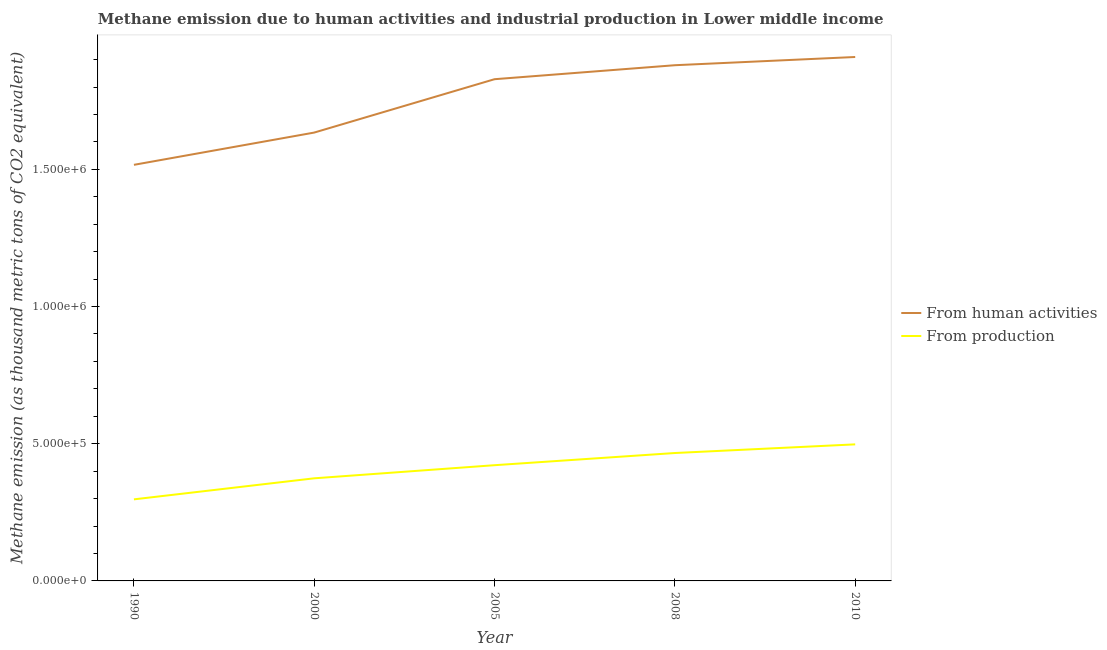How many different coloured lines are there?
Provide a succinct answer. 2. Does the line corresponding to amount of emissions generated from industries intersect with the line corresponding to amount of emissions from human activities?
Keep it short and to the point. No. Is the number of lines equal to the number of legend labels?
Your answer should be very brief. Yes. What is the amount of emissions from human activities in 2005?
Keep it short and to the point. 1.83e+06. Across all years, what is the maximum amount of emissions generated from industries?
Provide a short and direct response. 4.98e+05. Across all years, what is the minimum amount of emissions generated from industries?
Your answer should be very brief. 2.97e+05. What is the total amount of emissions generated from industries in the graph?
Make the answer very short. 2.06e+06. What is the difference between the amount of emissions from human activities in 2000 and that in 2010?
Provide a succinct answer. -2.75e+05. What is the difference between the amount of emissions from human activities in 2000 and the amount of emissions generated from industries in 1990?
Your response must be concise. 1.34e+06. What is the average amount of emissions from human activities per year?
Offer a terse response. 1.75e+06. In the year 2000, what is the difference between the amount of emissions from human activities and amount of emissions generated from industries?
Your answer should be compact. 1.26e+06. In how many years, is the amount of emissions generated from industries greater than 100000 thousand metric tons?
Your answer should be very brief. 5. What is the ratio of the amount of emissions from human activities in 1990 to that in 2008?
Offer a terse response. 0.81. Is the amount of emissions from human activities in 1990 less than that in 2005?
Offer a very short reply. Yes. Is the difference between the amount of emissions from human activities in 2005 and 2008 greater than the difference between the amount of emissions generated from industries in 2005 and 2008?
Offer a terse response. No. What is the difference between the highest and the second highest amount of emissions from human activities?
Keep it short and to the point. 3.00e+04. What is the difference between the highest and the lowest amount of emissions from human activities?
Keep it short and to the point. 3.93e+05. In how many years, is the amount of emissions generated from industries greater than the average amount of emissions generated from industries taken over all years?
Provide a short and direct response. 3. Does the amount of emissions generated from industries monotonically increase over the years?
Provide a short and direct response. Yes. Is the amount of emissions from human activities strictly greater than the amount of emissions generated from industries over the years?
Give a very brief answer. Yes. How many years are there in the graph?
Keep it short and to the point. 5. What is the difference between two consecutive major ticks on the Y-axis?
Provide a short and direct response. 5.00e+05. Are the values on the major ticks of Y-axis written in scientific E-notation?
Provide a short and direct response. Yes. Does the graph contain grids?
Your answer should be very brief. No. What is the title of the graph?
Your answer should be very brief. Methane emission due to human activities and industrial production in Lower middle income. What is the label or title of the X-axis?
Offer a terse response. Year. What is the label or title of the Y-axis?
Ensure brevity in your answer.  Methane emission (as thousand metric tons of CO2 equivalent). What is the Methane emission (as thousand metric tons of CO2 equivalent) in From human activities in 1990?
Offer a very short reply. 1.52e+06. What is the Methane emission (as thousand metric tons of CO2 equivalent) in From production in 1990?
Your answer should be compact. 2.97e+05. What is the Methane emission (as thousand metric tons of CO2 equivalent) in From human activities in 2000?
Make the answer very short. 1.63e+06. What is the Methane emission (as thousand metric tons of CO2 equivalent) of From production in 2000?
Offer a terse response. 3.74e+05. What is the Methane emission (as thousand metric tons of CO2 equivalent) in From human activities in 2005?
Offer a very short reply. 1.83e+06. What is the Methane emission (as thousand metric tons of CO2 equivalent) of From production in 2005?
Your answer should be very brief. 4.22e+05. What is the Methane emission (as thousand metric tons of CO2 equivalent) in From human activities in 2008?
Ensure brevity in your answer.  1.88e+06. What is the Methane emission (as thousand metric tons of CO2 equivalent) in From production in 2008?
Offer a very short reply. 4.66e+05. What is the Methane emission (as thousand metric tons of CO2 equivalent) of From human activities in 2010?
Your answer should be compact. 1.91e+06. What is the Methane emission (as thousand metric tons of CO2 equivalent) of From production in 2010?
Offer a very short reply. 4.98e+05. Across all years, what is the maximum Methane emission (as thousand metric tons of CO2 equivalent) of From human activities?
Provide a short and direct response. 1.91e+06. Across all years, what is the maximum Methane emission (as thousand metric tons of CO2 equivalent) of From production?
Ensure brevity in your answer.  4.98e+05. Across all years, what is the minimum Methane emission (as thousand metric tons of CO2 equivalent) in From human activities?
Your answer should be compact. 1.52e+06. Across all years, what is the minimum Methane emission (as thousand metric tons of CO2 equivalent) of From production?
Keep it short and to the point. 2.97e+05. What is the total Methane emission (as thousand metric tons of CO2 equivalent) of From human activities in the graph?
Offer a very short reply. 8.77e+06. What is the total Methane emission (as thousand metric tons of CO2 equivalent) of From production in the graph?
Provide a succinct answer. 2.06e+06. What is the difference between the Methane emission (as thousand metric tons of CO2 equivalent) in From human activities in 1990 and that in 2000?
Provide a short and direct response. -1.18e+05. What is the difference between the Methane emission (as thousand metric tons of CO2 equivalent) of From production in 1990 and that in 2000?
Provide a succinct answer. -7.67e+04. What is the difference between the Methane emission (as thousand metric tons of CO2 equivalent) in From human activities in 1990 and that in 2005?
Your answer should be very brief. -3.12e+05. What is the difference between the Methane emission (as thousand metric tons of CO2 equivalent) of From production in 1990 and that in 2005?
Make the answer very short. -1.24e+05. What is the difference between the Methane emission (as thousand metric tons of CO2 equivalent) in From human activities in 1990 and that in 2008?
Ensure brevity in your answer.  -3.63e+05. What is the difference between the Methane emission (as thousand metric tons of CO2 equivalent) of From production in 1990 and that in 2008?
Offer a terse response. -1.69e+05. What is the difference between the Methane emission (as thousand metric tons of CO2 equivalent) in From human activities in 1990 and that in 2010?
Ensure brevity in your answer.  -3.93e+05. What is the difference between the Methane emission (as thousand metric tons of CO2 equivalent) of From production in 1990 and that in 2010?
Your response must be concise. -2.00e+05. What is the difference between the Methane emission (as thousand metric tons of CO2 equivalent) in From human activities in 2000 and that in 2005?
Keep it short and to the point. -1.94e+05. What is the difference between the Methane emission (as thousand metric tons of CO2 equivalent) of From production in 2000 and that in 2005?
Your response must be concise. -4.78e+04. What is the difference between the Methane emission (as thousand metric tons of CO2 equivalent) in From human activities in 2000 and that in 2008?
Provide a short and direct response. -2.45e+05. What is the difference between the Methane emission (as thousand metric tons of CO2 equivalent) in From production in 2000 and that in 2008?
Give a very brief answer. -9.21e+04. What is the difference between the Methane emission (as thousand metric tons of CO2 equivalent) in From human activities in 2000 and that in 2010?
Provide a succinct answer. -2.75e+05. What is the difference between the Methane emission (as thousand metric tons of CO2 equivalent) of From production in 2000 and that in 2010?
Give a very brief answer. -1.24e+05. What is the difference between the Methane emission (as thousand metric tons of CO2 equivalent) in From human activities in 2005 and that in 2008?
Make the answer very short. -5.09e+04. What is the difference between the Methane emission (as thousand metric tons of CO2 equivalent) in From production in 2005 and that in 2008?
Give a very brief answer. -4.44e+04. What is the difference between the Methane emission (as thousand metric tons of CO2 equivalent) of From human activities in 2005 and that in 2010?
Provide a short and direct response. -8.09e+04. What is the difference between the Methane emission (as thousand metric tons of CO2 equivalent) in From production in 2005 and that in 2010?
Ensure brevity in your answer.  -7.59e+04. What is the difference between the Methane emission (as thousand metric tons of CO2 equivalent) of From human activities in 2008 and that in 2010?
Ensure brevity in your answer.  -3.00e+04. What is the difference between the Methane emission (as thousand metric tons of CO2 equivalent) in From production in 2008 and that in 2010?
Your response must be concise. -3.16e+04. What is the difference between the Methane emission (as thousand metric tons of CO2 equivalent) of From human activities in 1990 and the Methane emission (as thousand metric tons of CO2 equivalent) of From production in 2000?
Ensure brevity in your answer.  1.14e+06. What is the difference between the Methane emission (as thousand metric tons of CO2 equivalent) in From human activities in 1990 and the Methane emission (as thousand metric tons of CO2 equivalent) in From production in 2005?
Make the answer very short. 1.09e+06. What is the difference between the Methane emission (as thousand metric tons of CO2 equivalent) of From human activities in 1990 and the Methane emission (as thousand metric tons of CO2 equivalent) of From production in 2008?
Give a very brief answer. 1.05e+06. What is the difference between the Methane emission (as thousand metric tons of CO2 equivalent) of From human activities in 1990 and the Methane emission (as thousand metric tons of CO2 equivalent) of From production in 2010?
Provide a succinct answer. 1.02e+06. What is the difference between the Methane emission (as thousand metric tons of CO2 equivalent) of From human activities in 2000 and the Methane emission (as thousand metric tons of CO2 equivalent) of From production in 2005?
Ensure brevity in your answer.  1.21e+06. What is the difference between the Methane emission (as thousand metric tons of CO2 equivalent) of From human activities in 2000 and the Methane emission (as thousand metric tons of CO2 equivalent) of From production in 2008?
Your answer should be compact. 1.17e+06. What is the difference between the Methane emission (as thousand metric tons of CO2 equivalent) of From human activities in 2000 and the Methane emission (as thousand metric tons of CO2 equivalent) of From production in 2010?
Your answer should be very brief. 1.14e+06. What is the difference between the Methane emission (as thousand metric tons of CO2 equivalent) in From human activities in 2005 and the Methane emission (as thousand metric tons of CO2 equivalent) in From production in 2008?
Keep it short and to the point. 1.36e+06. What is the difference between the Methane emission (as thousand metric tons of CO2 equivalent) of From human activities in 2005 and the Methane emission (as thousand metric tons of CO2 equivalent) of From production in 2010?
Your answer should be compact. 1.33e+06. What is the difference between the Methane emission (as thousand metric tons of CO2 equivalent) in From human activities in 2008 and the Methane emission (as thousand metric tons of CO2 equivalent) in From production in 2010?
Your answer should be very brief. 1.38e+06. What is the average Methane emission (as thousand metric tons of CO2 equivalent) of From human activities per year?
Offer a very short reply. 1.75e+06. What is the average Methane emission (as thousand metric tons of CO2 equivalent) of From production per year?
Give a very brief answer. 4.11e+05. In the year 1990, what is the difference between the Methane emission (as thousand metric tons of CO2 equivalent) in From human activities and Methane emission (as thousand metric tons of CO2 equivalent) in From production?
Your response must be concise. 1.22e+06. In the year 2000, what is the difference between the Methane emission (as thousand metric tons of CO2 equivalent) of From human activities and Methane emission (as thousand metric tons of CO2 equivalent) of From production?
Your response must be concise. 1.26e+06. In the year 2005, what is the difference between the Methane emission (as thousand metric tons of CO2 equivalent) in From human activities and Methane emission (as thousand metric tons of CO2 equivalent) in From production?
Offer a terse response. 1.41e+06. In the year 2008, what is the difference between the Methane emission (as thousand metric tons of CO2 equivalent) in From human activities and Methane emission (as thousand metric tons of CO2 equivalent) in From production?
Offer a terse response. 1.41e+06. In the year 2010, what is the difference between the Methane emission (as thousand metric tons of CO2 equivalent) in From human activities and Methane emission (as thousand metric tons of CO2 equivalent) in From production?
Give a very brief answer. 1.41e+06. What is the ratio of the Methane emission (as thousand metric tons of CO2 equivalent) of From human activities in 1990 to that in 2000?
Provide a succinct answer. 0.93. What is the ratio of the Methane emission (as thousand metric tons of CO2 equivalent) in From production in 1990 to that in 2000?
Your answer should be compact. 0.79. What is the ratio of the Methane emission (as thousand metric tons of CO2 equivalent) of From human activities in 1990 to that in 2005?
Provide a succinct answer. 0.83. What is the ratio of the Methane emission (as thousand metric tons of CO2 equivalent) of From production in 1990 to that in 2005?
Your response must be concise. 0.7. What is the ratio of the Methane emission (as thousand metric tons of CO2 equivalent) of From human activities in 1990 to that in 2008?
Give a very brief answer. 0.81. What is the ratio of the Methane emission (as thousand metric tons of CO2 equivalent) of From production in 1990 to that in 2008?
Give a very brief answer. 0.64. What is the ratio of the Methane emission (as thousand metric tons of CO2 equivalent) in From human activities in 1990 to that in 2010?
Your answer should be compact. 0.79. What is the ratio of the Methane emission (as thousand metric tons of CO2 equivalent) in From production in 1990 to that in 2010?
Your answer should be compact. 0.6. What is the ratio of the Methane emission (as thousand metric tons of CO2 equivalent) in From human activities in 2000 to that in 2005?
Provide a short and direct response. 0.89. What is the ratio of the Methane emission (as thousand metric tons of CO2 equivalent) in From production in 2000 to that in 2005?
Your answer should be very brief. 0.89. What is the ratio of the Methane emission (as thousand metric tons of CO2 equivalent) of From human activities in 2000 to that in 2008?
Offer a terse response. 0.87. What is the ratio of the Methane emission (as thousand metric tons of CO2 equivalent) in From production in 2000 to that in 2008?
Ensure brevity in your answer.  0.8. What is the ratio of the Methane emission (as thousand metric tons of CO2 equivalent) in From human activities in 2000 to that in 2010?
Make the answer very short. 0.86. What is the ratio of the Methane emission (as thousand metric tons of CO2 equivalent) in From production in 2000 to that in 2010?
Provide a succinct answer. 0.75. What is the ratio of the Methane emission (as thousand metric tons of CO2 equivalent) of From human activities in 2005 to that in 2008?
Ensure brevity in your answer.  0.97. What is the ratio of the Methane emission (as thousand metric tons of CO2 equivalent) in From production in 2005 to that in 2008?
Your answer should be compact. 0.9. What is the ratio of the Methane emission (as thousand metric tons of CO2 equivalent) in From human activities in 2005 to that in 2010?
Provide a short and direct response. 0.96. What is the ratio of the Methane emission (as thousand metric tons of CO2 equivalent) of From production in 2005 to that in 2010?
Provide a short and direct response. 0.85. What is the ratio of the Methane emission (as thousand metric tons of CO2 equivalent) in From human activities in 2008 to that in 2010?
Provide a short and direct response. 0.98. What is the ratio of the Methane emission (as thousand metric tons of CO2 equivalent) of From production in 2008 to that in 2010?
Keep it short and to the point. 0.94. What is the difference between the highest and the second highest Methane emission (as thousand metric tons of CO2 equivalent) in From human activities?
Your answer should be very brief. 3.00e+04. What is the difference between the highest and the second highest Methane emission (as thousand metric tons of CO2 equivalent) of From production?
Give a very brief answer. 3.16e+04. What is the difference between the highest and the lowest Methane emission (as thousand metric tons of CO2 equivalent) in From human activities?
Keep it short and to the point. 3.93e+05. What is the difference between the highest and the lowest Methane emission (as thousand metric tons of CO2 equivalent) of From production?
Your response must be concise. 2.00e+05. 